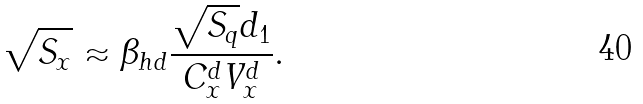Convert formula to latex. <formula><loc_0><loc_0><loc_500><loc_500>\sqrt { S _ { x } } \approx \beta _ { h d } \frac { \sqrt { S _ { q } } d _ { 1 } } { C _ { x } ^ { d } V _ { x } ^ { d } } .</formula> 